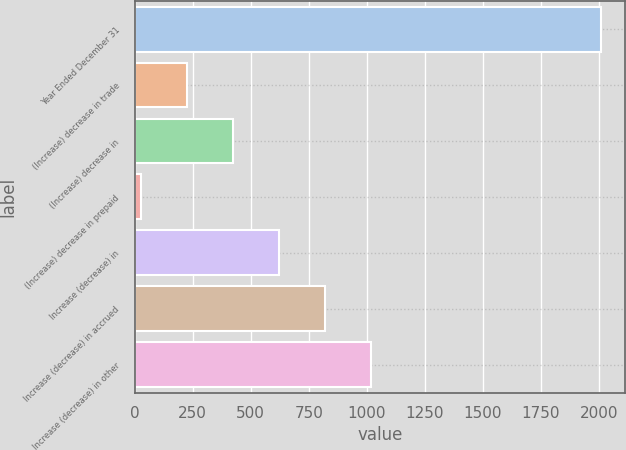<chart> <loc_0><loc_0><loc_500><loc_500><bar_chart><fcel>Year Ended December 31<fcel>(Increase) decrease in trade<fcel>(Increase) decrease in<fcel>(Increase) decrease in prepaid<fcel>Increase (decrease) in<fcel>Increase (decrease) in accrued<fcel>Increase (decrease) in other<nl><fcel>2012<fcel>227.3<fcel>425.6<fcel>29<fcel>623.9<fcel>822.2<fcel>1020.5<nl></chart> 